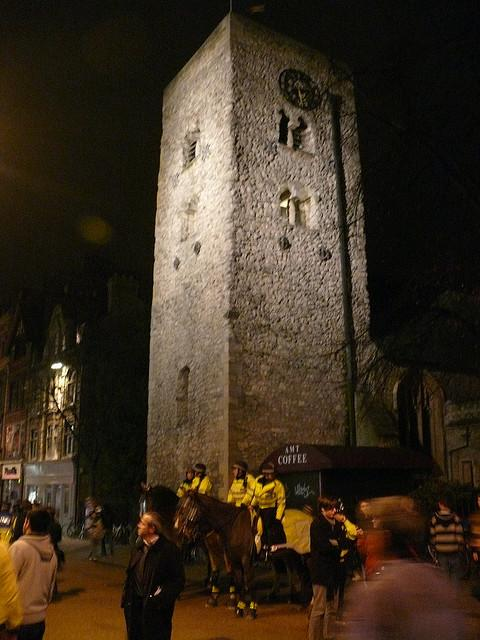What material is the construction of this tower?

Choices:
A) cobblestone
B) wood
C) brick
D) metal cobblestone 